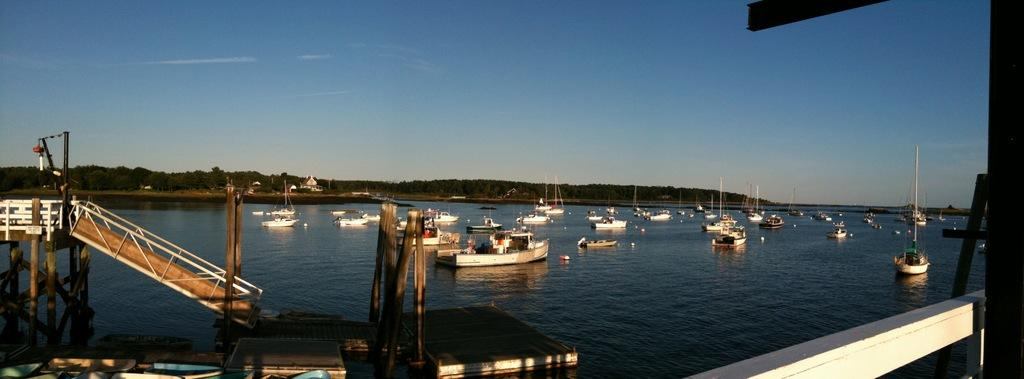What is located in the foreground of the image? There is a dock in the foreground of the image. What can be seen on the water in the image? There are ships and boats on the water. What type of vegetation is visible in the image? Trees are visible in the image. What is visible in the sky in the image? The sky is visible in the image, and clouds are present. What type of berry is growing on the dock in the image? There are no berries present in the image, and the dock does not have any plants growing on it. 